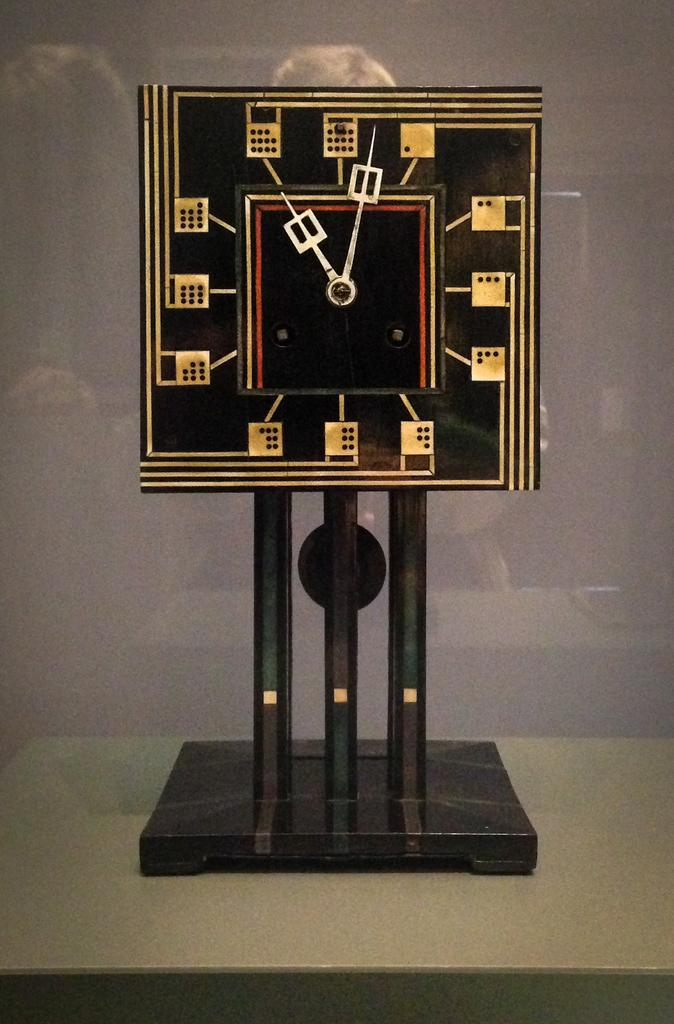What type of clock is featured in the image? There is a Charles Rennie Mackintosh clock in the image. Can you see a horse grazing in the background of the image? There is no horse present in the image; it features a Charles Rennie Mackintosh clock. What type of oil is used to maintain the clock in the image? The image does not provide information about the maintenance of the clock, nor does it mention any oil. 